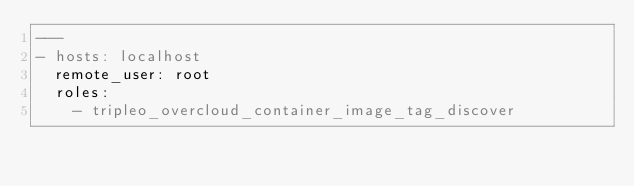Convert code to text. <code><loc_0><loc_0><loc_500><loc_500><_YAML_>---
- hosts: localhost
  remote_user: root
  roles:
    - tripleo_overcloud_container_image_tag_discover
</code> 